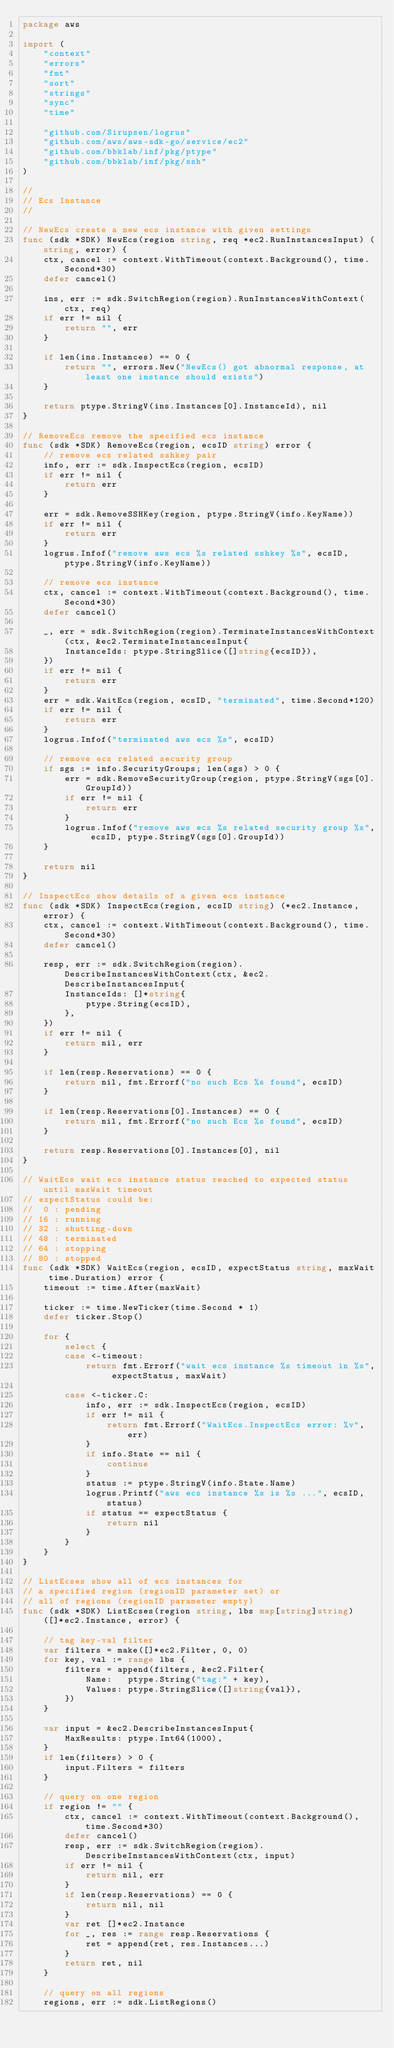<code> <loc_0><loc_0><loc_500><loc_500><_Go_>package aws

import (
	"context"
	"errors"
	"fmt"
	"sort"
	"strings"
	"sync"
	"time"

	"github.com/Sirupsen/logrus"
	"github.com/aws/aws-sdk-go/service/ec2"
	"github.com/bbklab/inf/pkg/ptype"
	"github.com/bbklab/inf/pkg/ssh"
)

//
// Ecs Instance
//

// NewEcs create a new ecs instance with given settings
func (sdk *SDK) NewEcs(region string, req *ec2.RunInstancesInput) (string, error) {
	ctx, cancel := context.WithTimeout(context.Background(), time.Second*30)
	defer cancel()

	ins, err := sdk.SwitchRegion(region).RunInstancesWithContext(ctx, req)
	if err != nil {
		return "", err
	}

	if len(ins.Instances) == 0 {
		return "", errors.New("NewEcs() got abnormal response, at least one instance should exists")
	}

	return ptype.StringV(ins.Instances[0].InstanceId), nil
}

// RemoveEcs remove the specified ecs instance
func (sdk *SDK) RemoveEcs(region, ecsID string) error {
	// remove ecs related sshkey pair
	info, err := sdk.InspectEcs(region, ecsID)
	if err != nil {
		return err
	}

	err = sdk.RemoveSSHKey(region, ptype.StringV(info.KeyName))
	if err != nil {
		return err
	}
	logrus.Infof("remove aws ecs %s related sshkey %s", ecsID, ptype.StringV(info.KeyName))

	// remove ecs instance
	ctx, cancel := context.WithTimeout(context.Background(), time.Second*30)
	defer cancel()

	_, err = sdk.SwitchRegion(region).TerminateInstancesWithContext(ctx, &ec2.TerminateInstancesInput{
		InstanceIds: ptype.StringSlice([]string{ecsID}),
	})
	if err != nil {
		return err
	}
	err = sdk.WaitEcs(region, ecsID, "terminated", time.Second*120)
	if err != nil {
		return err
	}
	logrus.Infof("terminated aws ecs %s", ecsID)

	// remove ecs related security group
	if sgs := info.SecurityGroups; len(sgs) > 0 {
		err = sdk.RemoveSecurityGroup(region, ptype.StringV(sgs[0].GroupId))
		if err != nil {
			return err
		}
		logrus.Infof("remove aws ecs %s related security group %s", ecsID, ptype.StringV(sgs[0].GroupId))
	}

	return nil
}

// InspectEcs show details of a given ecs instance
func (sdk *SDK) InspectEcs(region, ecsID string) (*ec2.Instance, error) {
	ctx, cancel := context.WithTimeout(context.Background(), time.Second*30)
	defer cancel()

	resp, err := sdk.SwitchRegion(region).DescribeInstancesWithContext(ctx, &ec2.DescribeInstancesInput{
		InstanceIds: []*string{
			ptype.String(ecsID),
		},
	})
	if err != nil {
		return nil, err
	}

	if len(resp.Reservations) == 0 {
		return nil, fmt.Errorf("no such Ecs %s found", ecsID)
	}

	if len(resp.Reservations[0].Instances) == 0 {
		return nil, fmt.Errorf("no such Ecs %s found", ecsID)
	}

	return resp.Reservations[0].Instances[0], nil
}

// WaitEcs wait ecs instance status reached to expected status until maxWait timeout
// expectStatus could be:
//  0 : pending
// 16 : running
// 32 : shutting-down
// 48 : terminated
// 64 : stopping
// 80 : stopped
func (sdk *SDK) WaitEcs(region, ecsID, expectStatus string, maxWait time.Duration) error {
	timeout := time.After(maxWait)

	ticker := time.NewTicker(time.Second * 1)
	defer ticker.Stop()

	for {
		select {
		case <-timeout:
			return fmt.Errorf("wait ecs instance %s timeout in %s", expectStatus, maxWait)

		case <-ticker.C:
			info, err := sdk.InspectEcs(region, ecsID)
			if err != nil {
				return fmt.Errorf("WaitEcs.InspectEcs error: %v", err)
			}
			if info.State == nil {
				continue
			}
			status := ptype.StringV(info.State.Name)
			logrus.Printf("aws ecs instance %s is %s ...", ecsID, status)
			if status == expectStatus {
				return nil
			}
		}
	}
}

// ListEcses show all of ecs instances for
// a specified region (regionID parameter set) or
// all of regions (regionID parameter empty)
func (sdk *SDK) ListEcses(region string, lbs map[string]string) ([]*ec2.Instance, error) {

	// tag key-val filter
	var filters = make([]*ec2.Filter, 0, 0)
	for key, val := range lbs {
		filters = append(filters, &ec2.Filter{
			Name:   ptype.String("tag:" + key),
			Values: ptype.StringSlice([]string{val}),
		})
	}

	var input = &ec2.DescribeInstancesInput{
		MaxResults: ptype.Int64(1000),
	}
	if len(filters) > 0 {
		input.Filters = filters
	}

	// query on one region
	if region != "" {
		ctx, cancel := context.WithTimeout(context.Background(), time.Second*30)
		defer cancel()
		resp, err := sdk.SwitchRegion(region).DescribeInstancesWithContext(ctx, input)
		if err != nil {
			return nil, err
		}
		if len(resp.Reservations) == 0 {
			return nil, nil
		}
		var ret []*ec2.Instance
		for _, res := range resp.Reservations {
			ret = append(ret, res.Instances...)
		}
		return ret, nil
	}

	// query on all regions
	regions, err := sdk.ListRegions()</code> 